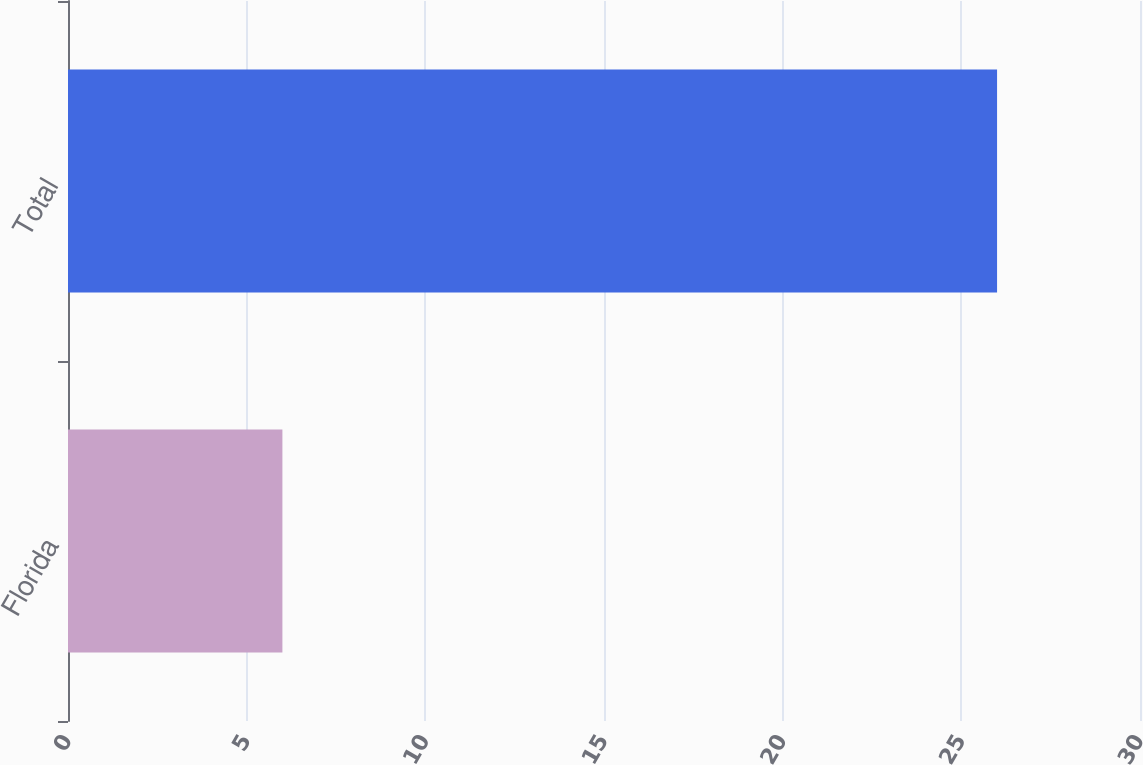Convert chart to OTSL. <chart><loc_0><loc_0><loc_500><loc_500><bar_chart><fcel>Florida<fcel>Total<nl><fcel>6<fcel>26<nl></chart> 